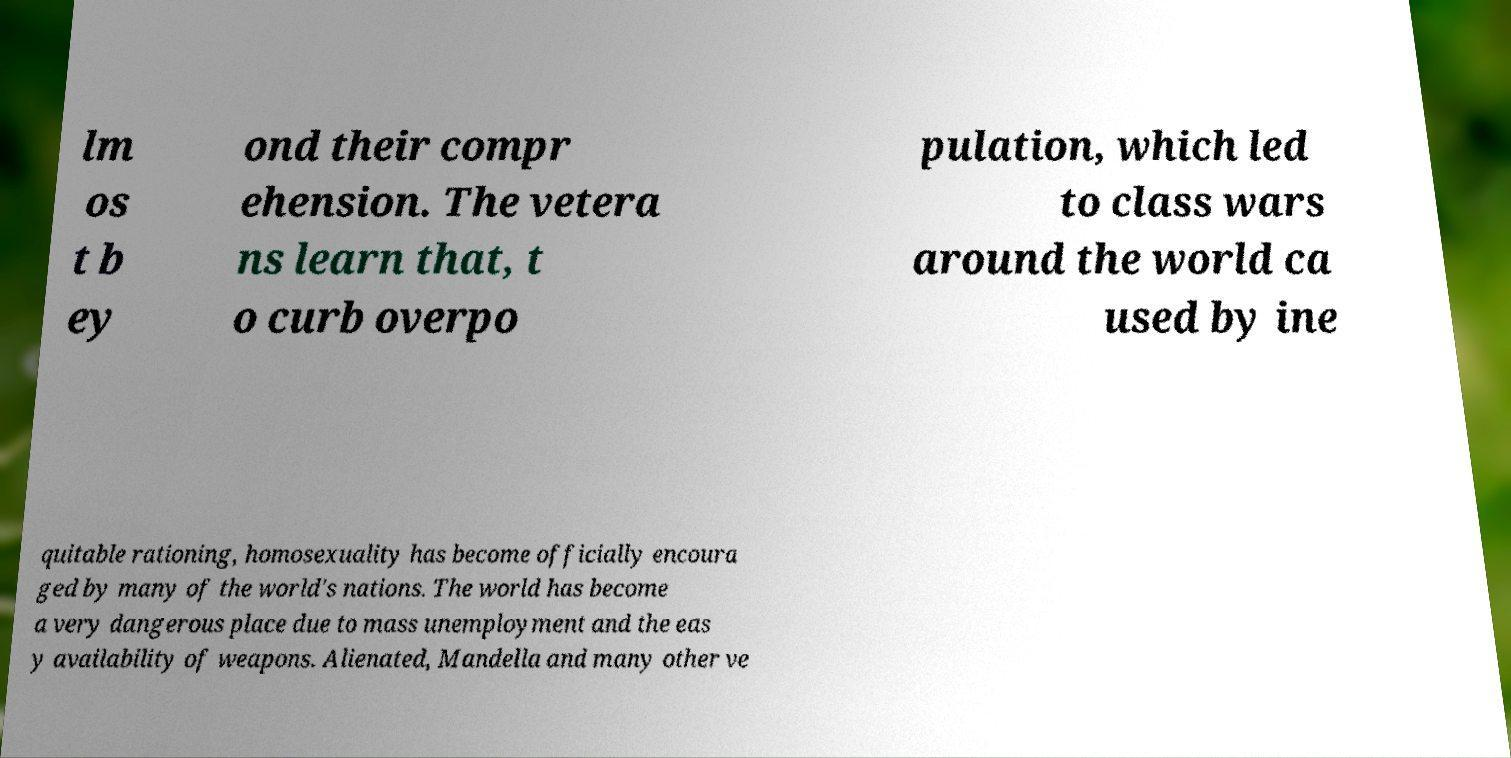Can you accurately transcribe the text from the provided image for me? lm os t b ey ond their compr ehension. The vetera ns learn that, t o curb overpo pulation, which led to class wars around the world ca used by ine quitable rationing, homosexuality has become officially encoura ged by many of the world's nations. The world has become a very dangerous place due to mass unemployment and the eas y availability of weapons. Alienated, Mandella and many other ve 